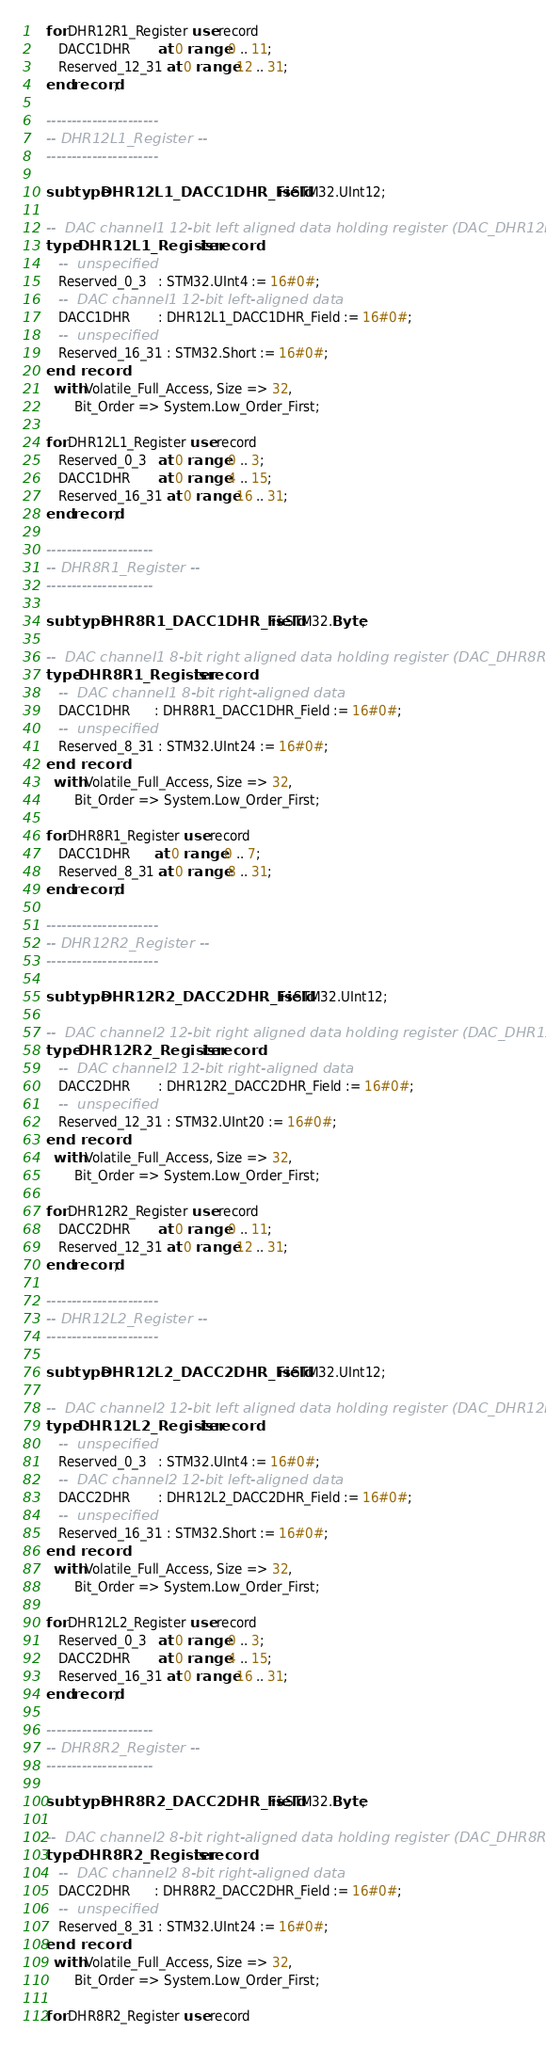<code> <loc_0><loc_0><loc_500><loc_500><_Ada_>
   for DHR12R1_Register use record
      DACC1DHR       at 0 range 0 .. 11;
      Reserved_12_31 at 0 range 12 .. 31;
   end record;

   ----------------------
   -- DHR12L1_Register --
   ----------------------

   subtype DHR12L1_DACC1DHR_Field is STM32.UInt12;

   --  DAC channel1 12-bit left aligned data holding register (DAC_DHR12L1)
   type DHR12L1_Register is record
      --  unspecified
      Reserved_0_3   : STM32.UInt4 := 16#0#;
      --  DAC channel1 12-bit left-aligned data
      DACC1DHR       : DHR12L1_DACC1DHR_Field := 16#0#;
      --  unspecified
      Reserved_16_31 : STM32.Short := 16#0#;
   end record
     with Volatile_Full_Access, Size => 32,
          Bit_Order => System.Low_Order_First;

   for DHR12L1_Register use record
      Reserved_0_3   at 0 range 0 .. 3;
      DACC1DHR       at 0 range 4 .. 15;
      Reserved_16_31 at 0 range 16 .. 31;
   end record;

   ---------------------
   -- DHR8R1_Register --
   ---------------------

   subtype DHR8R1_DACC1DHR_Field is STM32.Byte;

   --  DAC channel1 8-bit right aligned data holding register (DAC_DHR8R1)
   type DHR8R1_Register is record
      --  DAC channel1 8-bit right-aligned data
      DACC1DHR      : DHR8R1_DACC1DHR_Field := 16#0#;
      --  unspecified
      Reserved_8_31 : STM32.UInt24 := 16#0#;
   end record
     with Volatile_Full_Access, Size => 32,
          Bit_Order => System.Low_Order_First;

   for DHR8R1_Register use record
      DACC1DHR      at 0 range 0 .. 7;
      Reserved_8_31 at 0 range 8 .. 31;
   end record;

   ----------------------
   -- DHR12R2_Register --
   ----------------------

   subtype DHR12R2_DACC2DHR_Field is STM32.UInt12;

   --  DAC channel2 12-bit right aligned data holding register (DAC_DHR12R2)
   type DHR12R2_Register is record
      --  DAC channel2 12-bit right-aligned data
      DACC2DHR       : DHR12R2_DACC2DHR_Field := 16#0#;
      --  unspecified
      Reserved_12_31 : STM32.UInt20 := 16#0#;
   end record
     with Volatile_Full_Access, Size => 32,
          Bit_Order => System.Low_Order_First;

   for DHR12R2_Register use record
      DACC2DHR       at 0 range 0 .. 11;
      Reserved_12_31 at 0 range 12 .. 31;
   end record;

   ----------------------
   -- DHR12L2_Register --
   ----------------------

   subtype DHR12L2_DACC2DHR_Field is STM32.UInt12;

   --  DAC channel2 12-bit left aligned data holding register (DAC_DHR12L2)
   type DHR12L2_Register is record
      --  unspecified
      Reserved_0_3   : STM32.UInt4 := 16#0#;
      --  DAC channel2 12-bit left-aligned data
      DACC2DHR       : DHR12L2_DACC2DHR_Field := 16#0#;
      --  unspecified
      Reserved_16_31 : STM32.Short := 16#0#;
   end record
     with Volatile_Full_Access, Size => 32,
          Bit_Order => System.Low_Order_First;

   for DHR12L2_Register use record
      Reserved_0_3   at 0 range 0 .. 3;
      DACC2DHR       at 0 range 4 .. 15;
      Reserved_16_31 at 0 range 16 .. 31;
   end record;

   ---------------------
   -- DHR8R2_Register --
   ---------------------

   subtype DHR8R2_DACC2DHR_Field is STM32.Byte;

   --  DAC channel2 8-bit right-aligned data holding register (DAC_DHR8R2)
   type DHR8R2_Register is record
      --  DAC channel2 8-bit right-aligned data
      DACC2DHR      : DHR8R2_DACC2DHR_Field := 16#0#;
      --  unspecified
      Reserved_8_31 : STM32.UInt24 := 16#0#;
   end record
     with Volatile_Full_Access, Size => 32,
          Bit_Order => System.Low_Order_First;

   for DHR8R2_Register use record</code> 